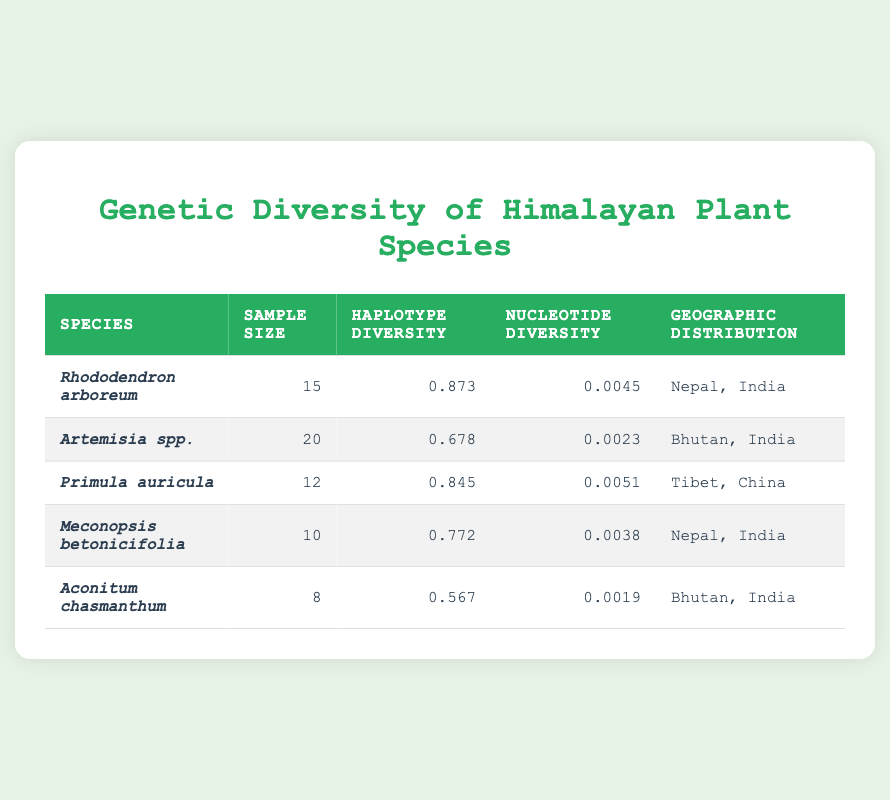What is the sample size for the species Rhododendron arboreum? The table lists sample sizes for each species. By locating Rhododendron arboreum in the "Species" column, the corresponding value in the "Sample Size" column is 15.
Answer: 15 Which species has the highest haplotype diversity? To find the species with the highest haplotype diversity, I compare the values in the "Haplotype Diversity" column. The highest value is 0.873 for Rhododendron arboreum.
Answer: Rhododendron arboreum Is the nucleotide diversity for Aconitum chasmanthum greater than 0.0020? The "Nucleotide Diversity" for Aconitum chasmanthum is listed as 0.0019, which is less than 0.0020.
Answer: No What is the average sample size of all the plant species listed? The sample sizes are 15, 20, 12, 10, and 8. I calculate the average by summing these values (15 + 20 + 12 + 10 + 8) = 65. Then, I divide by the number of species, which is 5. Therefore, the average sample size is 65 / 5 = 13.
Answer: 13 Are all species from the geographic distribution of Nepal and India showing high haplotype diversity? There are two species from Nepal and India: Rhododendron arboreum (haplotype diversity 0.873) and Meconopsis betonicifolia (haplotype diversity 0.772). Both values are relatively high, being above 0.7, indicating they have high genetic diversity.
Answer: Yes What is the difference in nucleotide diversity between Primula auricula and Artemisia spp.? The nucleotide diversity for Primula auricula is 0.0051 and for Artemisia spp. it is 0.0023. To find the difference, I subtract these two values: 0.0051 - 0.0023 = 0.0028.
Answer: 0.0028 How many species analyzed have a haplotype diversity lower than 0.7? I check the "Haplotype Diversity" column for values lower than 0.7. Aconitum chasmanthum (0.567) is the only species that meets this criterion. Therefore, there is 1 species with haplotype diversity lower than 0.7.
Answer: 1 Which species has the lowest nucleotide diversity and what is that value? The table shows Aconitum chasmanthum with a nucleotide diversity of 0.0019. I can confirm that this is lower than all other listed values.
Answer: Aconitum chasmanthum, 0.0019 What is the total haplotype diversity of all the species combined? To find the total haplotype diversity, I add the haplotype diversity values: 0.873 + 0.678 + 0.845 + 0.772 + 0.567 = 3.735. This gives a combined haplotype diversity of 3.735.
Answer: 3.735 